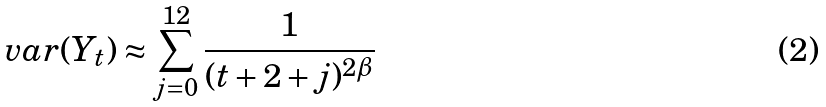Convert formula to latex. <formula><loc_0><loc_0><loc_500><loc_500>v a r ( Y _ { t } ) \approx \sum _ { j = 0 } ^ { 1 2 } \frac { 1 } { ( t + 2 + j ) ^ { 2 \beta } }</formula> 